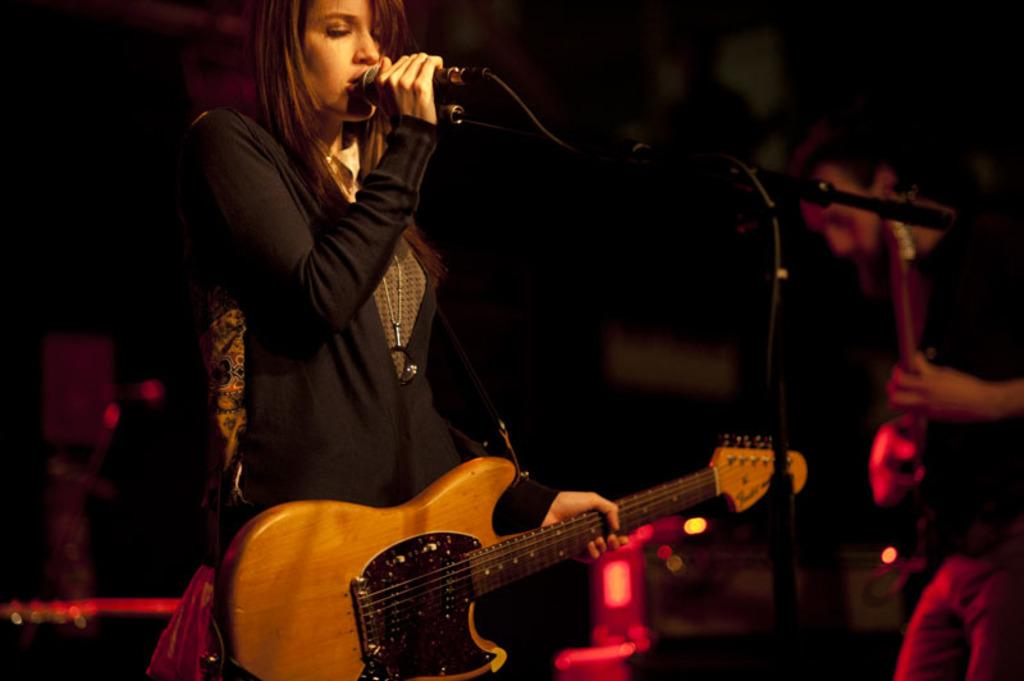What is the main subject of the image? The main subject of the image is a woman. What is the woman doing in the image? The woman is standing, singing a song, and holding a microphone and a guitar. Is there anyone else in the image? Yes, there is another person in the background of the image. What is the person in the background doing? The person in the background is standing and playing a guitar. What type of bun is the woman wearing in the image? There is no mention of a bun in the image, and the woman's hairstyle is not described. Is there a rainstorm happening in the image? There is no indication of a rainstorm in the image; the weather is not mentioned. 